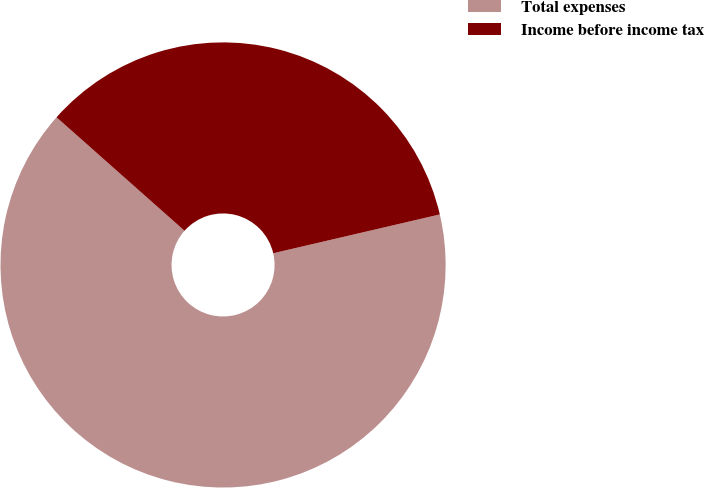<chart> <loc_0><loc_0><loc_500><loc_500><pie_chart><fcel>Total expenses<fcel>Income before income tax<nl><fcel>65.19%<fcel>34.81%<nl></chart> 